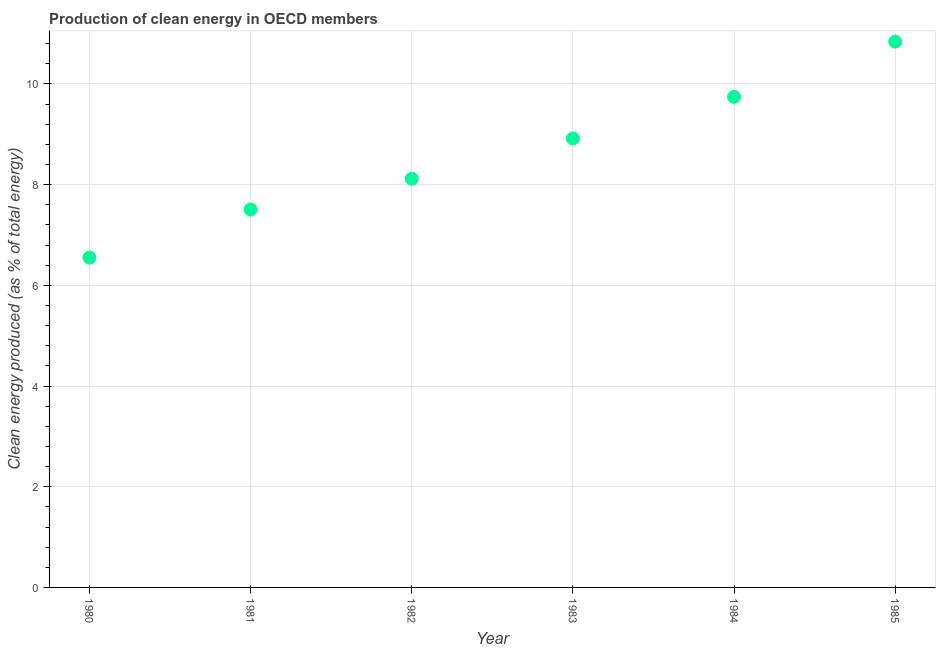What is the production of clean energy in 1983?
Give a very brief answer. 8.92. Across all years, what is the maximum production of clean energy?
Your answer should be compact. 10.84. Across all years, what is the minimum production of clean energy?
Ensure brevity in your answer.  6.55. In which year was the production of clean energy minimum?
Keep it short and to the point. 1980. What is the sum of the production of clean energy?
Provide a short and direct response. 51.68. What is the difference between the production of clean energy in 1981 and 1984?
Your response must be concise. -2.24. What is the average production of clean energy per year?
Provide a succinct answer. 8.61. What is the median production of clean energy?
Make the answer very short. 8.52. In how many years, is the production of clean energy greater than 1.6 %?
Your answer should be very brief. 6. Do a majority of the years between 1980 and 1983 (inclusive) have production of clean energy greater than 4 %?
Offer a very short reply. Yes. What is the ratio of the production of clean energy in 1982 to that in 1983?
Offer a very short reply. 0.91. What is the difference between the highest and the second highest production of clean energy?
Your response must be concise. 1.1. What is the difference between the highest and the lowest production of clean energy?
Your answer should be compact. 4.29. What is the title of the graph?
Offer a very short reply. Production of clean energy in OECD members. What is the label or title of the X-axis?
Ensure brevity in your answer.  Year. What is the label or title of the Y-axis?
Your answer should be very brief. Clean energy produced (as % of total energy). What is the Clean energy produced (as % of total energy) in 1980?
Your response must be concise. 6.55. What is the Clean energy produced (as % of total energy) in 1981?
Offer a terse response. 7.5. What is the Clean energy produced (as % of total energy) in 1982?
Provide a short and direct response. 8.12. What is the Clean energy produced (as % of total energy) in 1983?
Give a very brief answer. 8.92. What is the Clean energy produced (as % of total energy) in 1984?
Provide a short and direct response. 9.74. What is the Clean energy produced (as % of total energy) in 1985?
Offer a very short reply. 10.84. What is the difference between the Clean energy produced (as % of total energy) in 1980 and 1981?
Ensure brevity in your answer.  -0.95. What is the difference between the Clean energy produced (as % of total energy) in 1980 and 1982?
Give a very brief answer. -1.57. What is the difference between the Clean energy produced (as % of total energy) in 1980 and 1983?
Give a very brief answer. -2.37. What is the difference between the Clean energy produced (as % of total energy) in 1980 and 1984?
Your answer should be compact. -3.19. What is the difference between the Clean energy produced (as % of total energy) in 1980 and 1985?
Keep it short and to the point. -4.29. What is the difference between the Clean energy produced (as % of total energy) in 1981 and 1982?
Provide a short and direct response. -0.61. What is the difference between the Clean energy produced (as % of total energy) in 1981 and 1983?
Ensure brevity in your answer.  -1.41. What is the difference between the Clean energy produced (as % of total energy) in 1981 and 1984?
Your answer should be compact. -2.24. What is the difference between the Clean energy produced (as % of total energy) in 1981 and 1985?
Offer a very short reply. -3.34. What is the difference between the Clean energy produced (as % of total energy) in 1982 and 1983?
Your response must be concise. -0.8. What is the difference between the Clean energy produced (as % of total energy) in 1982 and 1984?
Your answer should be very brief. -1.63. What is the difference between the Clean energy produced (as % of total energy) in 1982 and 1985?
Give a very brief answer. -2.72. What is the difference between the Clean energy produced (as % of total energy) in 1983 and 1984?
Provide a short and direct response. -0.83. What is the difference between the Clean energy produced (as % of total energy) in 1983 and 1985?
Ensure brevity in your answer.  -1.92. What is the difference between the Clean energy produced (as % of total energy) in 1984 and 1985?
Your answer should be very brief. -1.1. What is the ratio of the Clean energy produced (as % of total energy) in 1980 to that in 1981?
Give a very brief answer. 0.87. What is the ratio of the Clean energy produced (as % of total energy) in 1980 to that in 1982?
Provide a succinct answer. 0.81. What is the ratio of the Clean energy produced (as % of total energy) in 1980 to that in 1983?
Ensure brevity in your answer.  0.73. What is the ratio of the Clean energy produced (as % of total energy) in 1980 to that in 1984?
Your response must be concise. 0.67. What is the ratio of the Clean energy produced (as % of total energy) in 1980 to that in 1985?
Ensure brevity in your answer.  0.6. What is the ratio of the Clean energy produced (as % of total energy) in 1981 to that in 1982?
Ensure brevity in your answer.  0.93. What is the ratio of the Clean energy produced (as % of total energy) in 1981 to that in 1983?
Keep it short and to the point. 0.84. What is the ratio of the Clean energy produced (as % of total energy) in 1981 to that in 1984?
Your answer should be very brief. 0.77. What is the ratio of the Clean energy produced (as % of total energy) in 1981 to that in 1985?
Provide a short and direct response. 0.69. What is the ratio of the Clean energy produced (as % of total energy) in 1982 to that in 1983?
Offer a very short reply. 0.91. What is the ratio of the Clean energy produced (as % of total energy) in 1982 to that in 1984?
Ensure brevity in your answer.  0.83. What is the ratio of the Clean energy produced (as % of total energy) in 1982 to that in 1985?
Offer a very short reply. 0.75. What is the ratio of the Clean energy produced (as % of total energy) in 1983 to that in 1984?
Your response must be concise. 0.92. What is the ratio of the Clean energy produced (as % of total energy) in 1983 to that in 1985?
Provide a short and direct response. 0.82. What is the ratio of the Clean energy produced (as % of total energy) in 1984 to that in 1985?
Your answer should be compact. 0.9. 